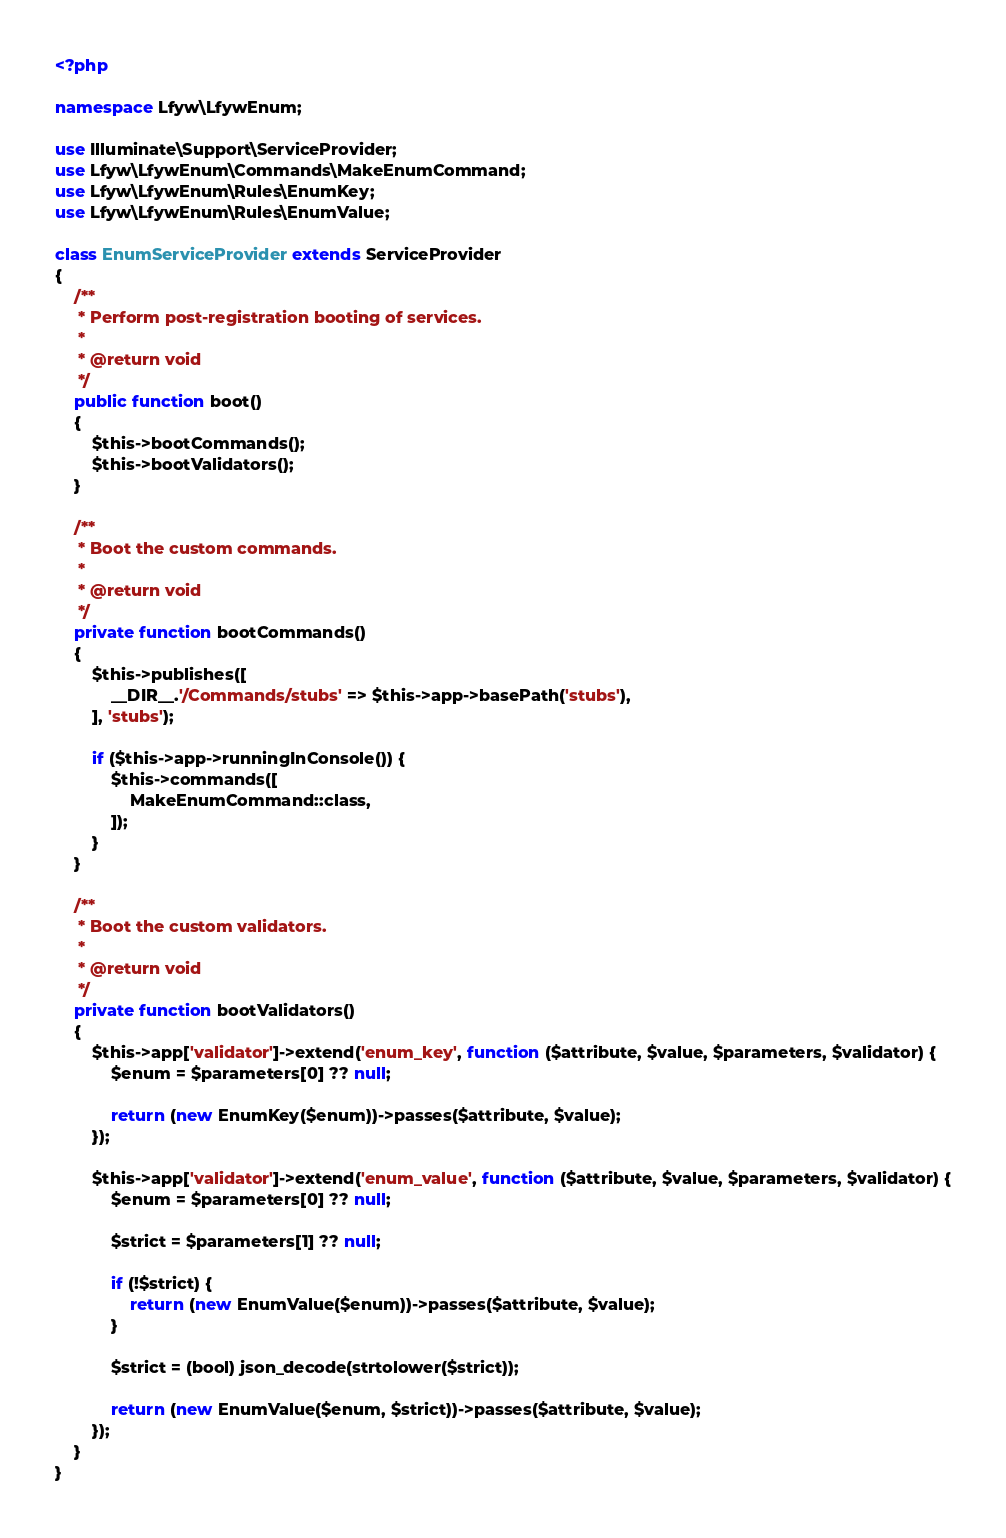<code> <loc_0><loc_0><loc_500><loc_500><_PHP_><?php

namespace Lfyw\LfywEnum;

use Illuminate\Support\ServiceProvider;
use Lfyw\LfywEnum\Commands\MakeEnumCommand;
use Lfyw\LfywEnum\Rules\EnumKey;
use Lfyw\LfywEnum\Rules\EnumValue;

class EnumServiceProvider extends ServiceProvider
{
    /**
     * Perform post-registration booting of services.
     *
     * @return void
     */
    public function boot()
    {
        $this->bootCommands();
        $this->bootValidators();
    }

    /**
     * Boot the custom commands.
     *
     * @return void
     */
    private function bootCommands()
    {
        $this->publishes([
            __DIR__.'/Commands/stubs' => $this->app->basePath('stubs'),
        ], 'stubs');

        if ($this->app->runningInConsole()) {
            $this->commands([
                MakeEnumCommand::class,
            ]);
        }
    }

    /**
     * Boot the custom validators.
     *
     * @return void
     */
    private function bootValidators()
    {
        $this->app['validator']->extend('enum_key', function ($attribute, $value, $parameters, $validator) {
            $enum = $parameters[0] ?? null;

            return (new EnumKey($enum))->passes($attribute, $value);
        });

        $this->app['validator']->extend('enum_value', function ($attribute, $value, $parameters, $validator) {
            $enum = $parameters[0] ?? null;

            $strict = $parameters[1] ?? null;

            if (!$strict) {
                return (new EnumValue($enum))->passes($attribute, $value);
            }

            $strict = (bool) json_decode(strtolower($strict));

            return (new EnumValue($enum, $strict))->passes($attribute, $value);
        });
    }
}
</code> 